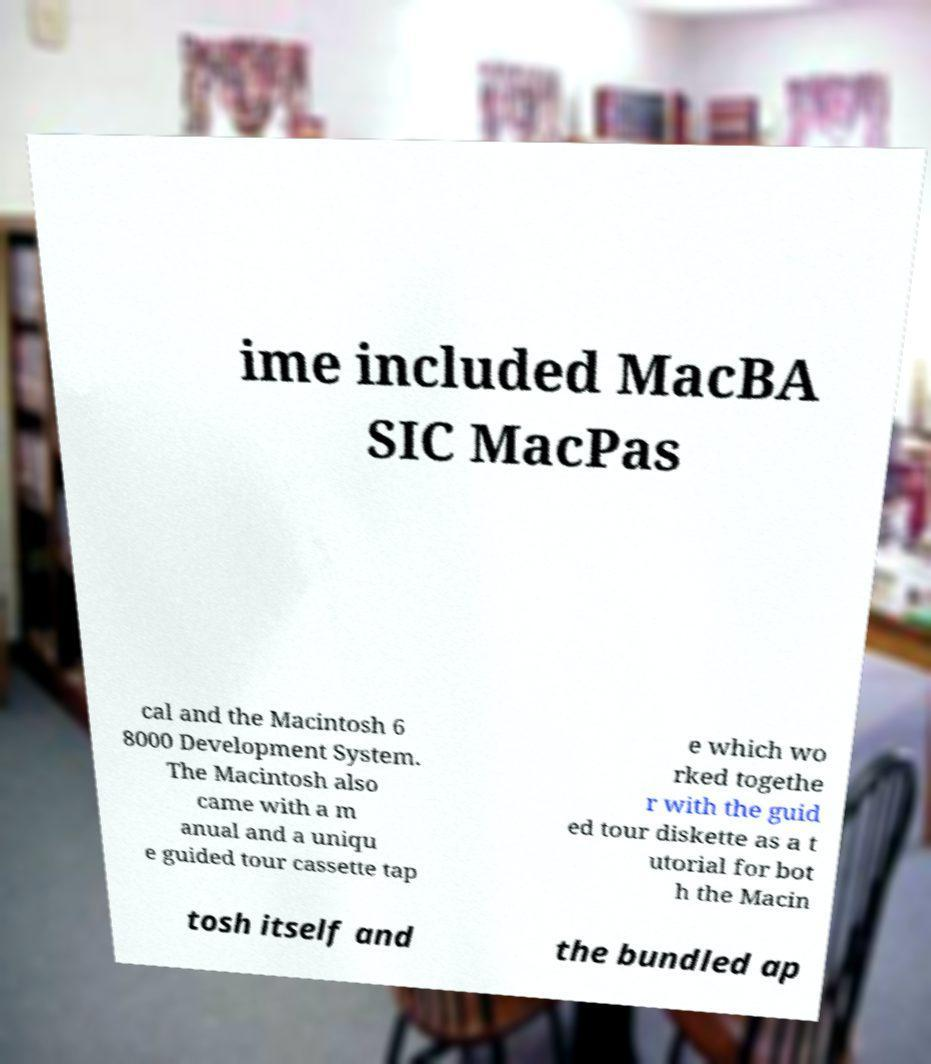What messages or text are displayed in this image? I need them in a readable, typed format. ime included MacBA SIC MacPas cal and the Macintosh 6 8000 Development System. The Macintosh also came with a m anual and a uniqu e guided tour cassette tap e which wo rked togethe r with the guid ed tour diskette as a t utorial for bot h the Macin tosh itself and the bundled ap 